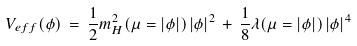<formula> <loc_0><loc_0><loc_500><loc_500>V _ { e f f } ( \phi ) \, = \, \frac { 1 } { 2 } m _ { H } ^ { 2 } ( \mu = | \phi | ) \, | \phi | ^ { 2 } \, + \, \frac { 1 } { 8 } \lambda ( \mu = | \phi | ) \, | \phi | ^ { 4 }</formula> 